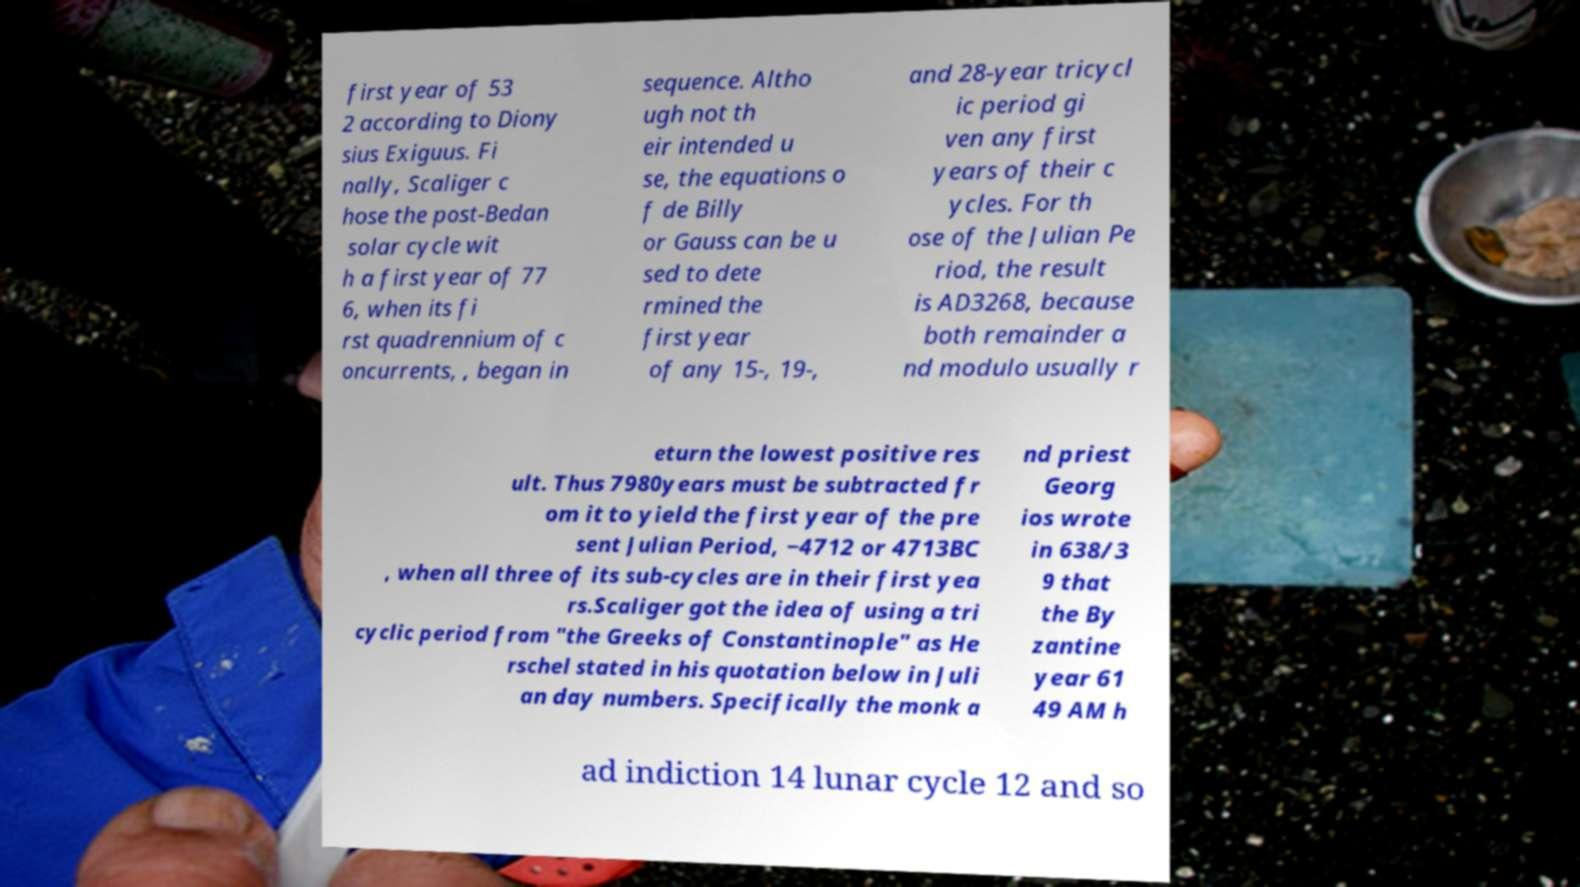For documentation purposes, I need the text within this image transcribed. Could you provide that? first year of 53 2 according to Diony sius Exiguus. Fi nally, Scaliger c hose the post-Bedan solar cycle wit h a first year of 77 6, when its fi rst quadrennium of c oncurrents, , began in sequence. Altho ugh not th eir intended u se, the equations o f de Billy or Gauss can be u sed to dete rmined the first year of any 15-, 19-, and 28-year tricycl ic period gi ven any first years of their c ycles. For th ose of the Julian Pe riod, the result is AD3268, because both remainder a nd modulo usually r eturn the lowest positive res ult. Thus 7980years must be subtracted fr om it to yield the first year of the pre sent Julian Period, −4712 or 4713BC , when all three of its sub-cycles are in their first yea rs.Scaliger got the idea of using a tri cyclic period from "the Greeks of Constantinople" as He rschel stated in his quotation below in Juli an day numbers. Specifically the monk a nd priest Georg ios wrote in 638/3 9 that the By zantine year 61 49 AM h ad indiction 14 lunar cycle 12 and so 